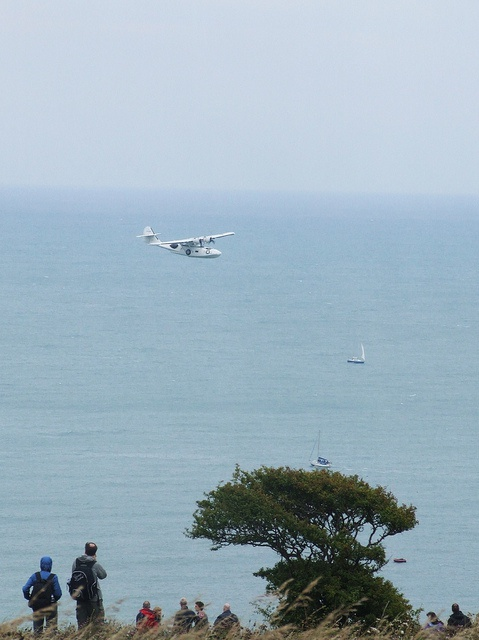Describe the objects in this image and their specific colors. I can see people in lightgray, black, navy, gray, and blue tones, airplane in lightgray, darkgray, gray, and lightblue tones, backpack in lightgray, black, gray, and darkblue tones, backpack in lightgray, black, navy, gray, and darkblue tones, and people in lightgray, gray, black, and darkgray tones in this image. 